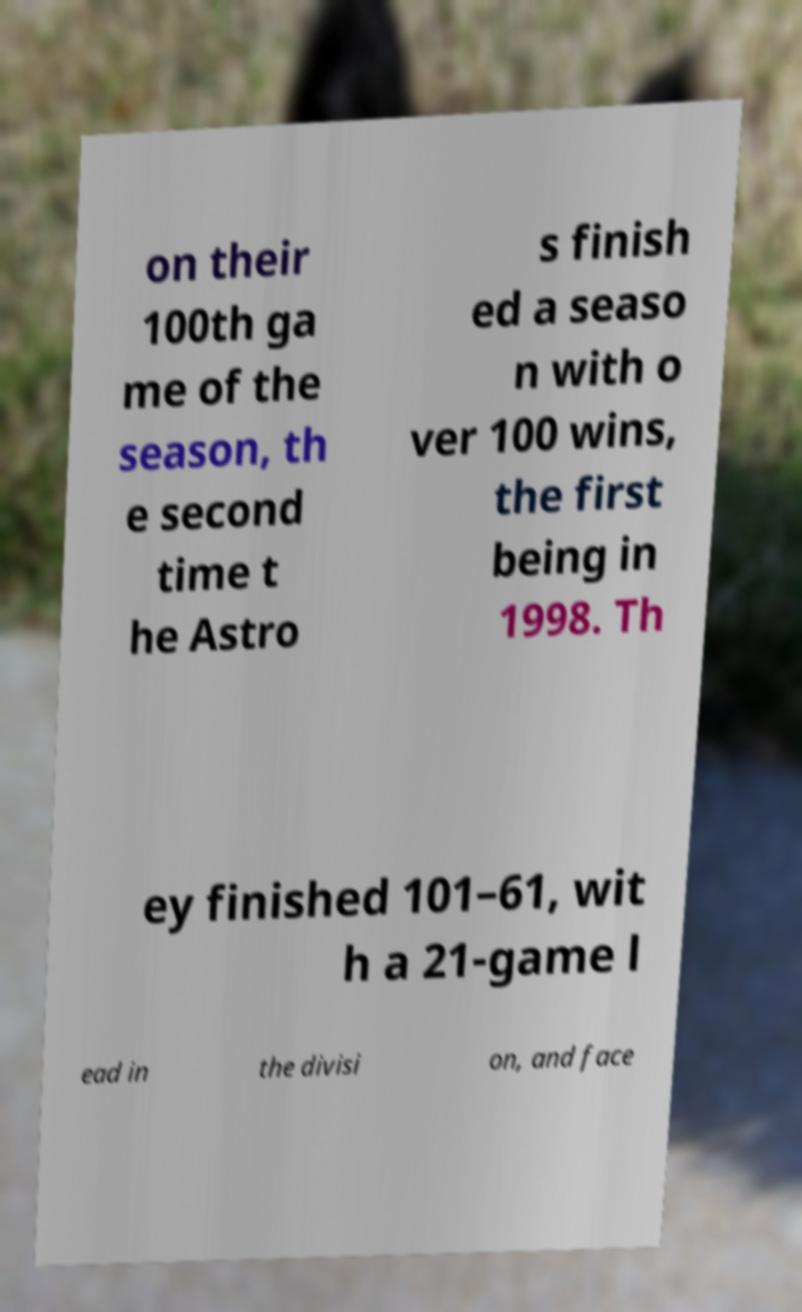For documentation purposes, I need the text within this image transcribed. Could you provide that? on their 100th ga me of the season, th e second time t he Astro s finish ed a seaso n with o ver 100 wins, the first being in 1998. Th ey finished 101–61, wit h a 21-game l ead in the divisi on, and face 